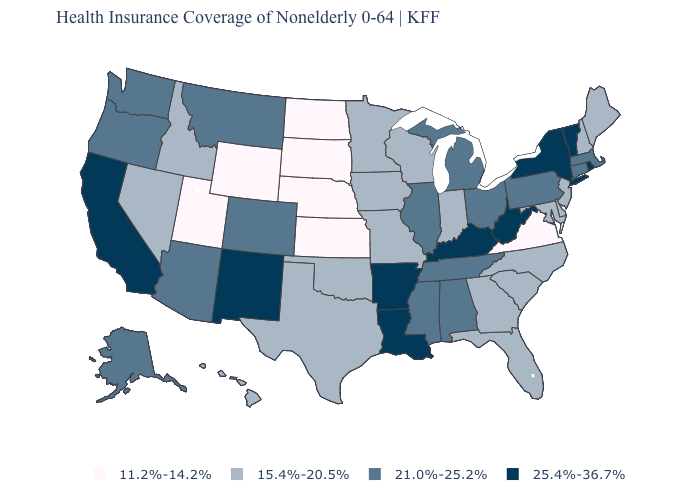Name the states that have a value in the range 25.4%-36.7%?
Short answer required. Arkansas, California, Kentucky, Louisiana, New Mexico, New York, Rhode Island, Vermont, West Virginia. How many symbols are there in the legend?
Give a very brief answer. 4. What is the value of Missouri?
Be succinct. 15.4%-20.5%. Name the states that have a value in the range 25.4%-36.7%?
Answer briefly. Arkansas, California, Kentucky, Louisiana, New Mexico, New York, Rhode Island, Vermont, West Virginia. Among the states that border Illinois , which have the highest value?
Give a very brief answer. Kentucky. What is the highest value in states that border Kansas?
Keep it brief. 21.0%-25.2%. What is the lowest value in the Northeast?
Answer briefly. 15.4%-20.5%. Name the states that have a value in the range 11.2%-14.2%?
Be succinct. Kansas, Nebraska, North Dakota, South Dakota, Utah, Virginia, Wyoming. Which states have the lowest value in the USA?
Short answer required. Kansas, Nebraska, North Dakota, South Dakota, Utah, Virginia, Wyoming. Does Wisconsin have the highest value in the MidWest?
Be succinct. No. Which states have the highest value in the USA?
Concise answer only. Arkansas, California, Kentucky, Louisiana, New Mexico, New York, Rhode Island, Vermont, West Virginia. What is the highest value in the USA?
Keep it brief. 25.4%-36.7%. Name the states that have a value in the range 25.4%-36.7%?
Answer briefly. Arkansas, California, Kentucky, Louisiana, New Mexico, New York, Rhode Island, Vermont, West Virginia. Which states have the lowest value in the USA?
Give a very brief answer. Kansas, Nebraska, North Dakota, South Dakota, Utah, Virginia, Wyoming. What is the highest value in the MidWest ?
Give a very brief answer. 21.0%-25.2%. 